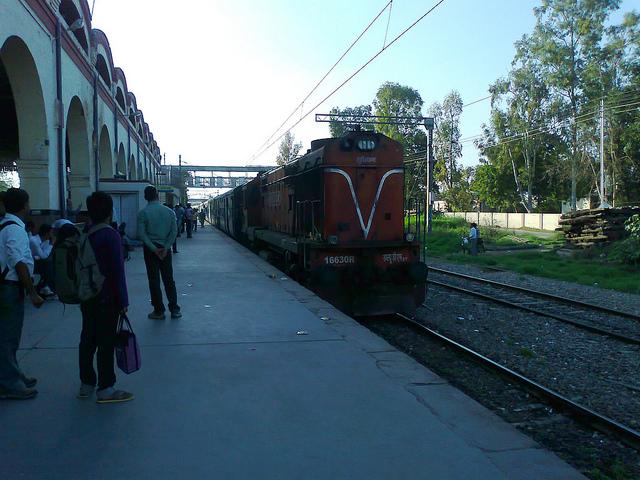Where is the train heading?
Be succinct. Right. What city is this train station located in?
Answer briefly. Unknown. Is the train coming or going?
Answer briefly. Coming. 